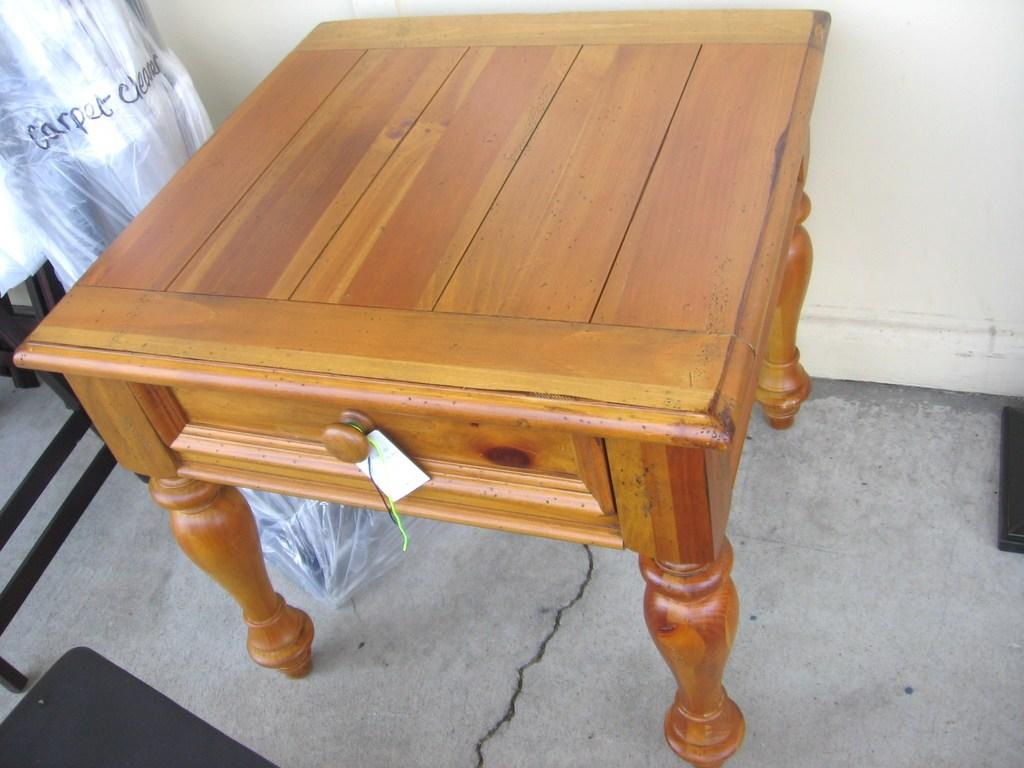What piece of furniture is present in the image? There is a table in the image. Is there any additional information about the table? Yes, there is a tag on the table. What else can be seen near the table? There is an object covered with a cover beside the table. What color is the object at the bottom of the image? The object at the bottom of the image is black. How many tickets are visible in the image? There are no tickets present in the image. What type of wood is the table made of in the image? The facts provided do not mention the material of the table, so we cannot determine if it is made of wood or any other material. 